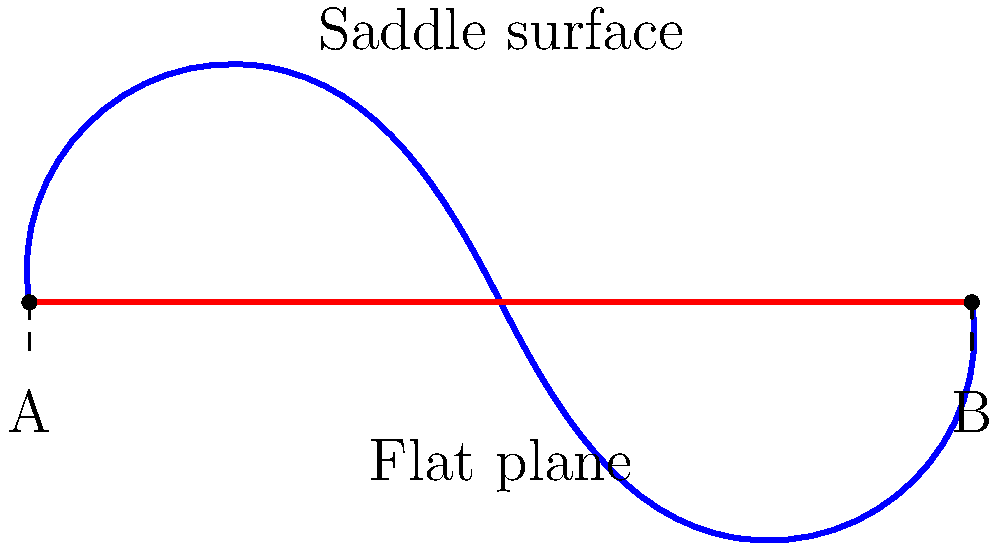As a campus wellness coordinator promoting healthy eating habits, you're designing an interactive display to show how food choices impact overall well-being. You decide to use a non-Euclidean geometry concept to illustrate this. In the diagram, the blue curve represents a saddle-shaped surface, and the red line represents a flat plane. Both connect points A and B. How does the distance between A and B on the saddle surface compare to the distance on the flat plane, and how might this relate to making balanced food choices? To understand this concept and relate it to balanced food choices, let's break it down step-by-step:

1. In Euclidean geometry (flat plane):
   - The shortest distance between two points is a straight line.
   - This is represented by the red line in the diagram.

2. In Non-Euclidean geometry (saddle surface):
   - The shortest path between two points is not necessarily a straight line.
   - The blue curve represents this path on the saddle surface.

3. Comparison of distances:
   - The blue curve (saddle surface path) is longer than the red line (flat plane path).
   - This is because the saddle surface has curvature, causing the path to deviate from a straight line.

4. Relating to balanced food choices:
   - The flat plane (red line) could represent a simplistic view of nutrition, focusing on just one aspect (e.g., calorie counting).
   - The saddle surface (blue curve) could represent a more holistic approach to nutrition, considering multiple factors (e.g., macronutrients, micronutrients, portion sizes, timing of meals).

5. Implications for wellness:
   - Just as the shortest path in non-Euclidean geometry isn't always a straight line, the best approach to nutrition isn't always the most straightforward.
   - A balanced diet may require more "distance" or effort but leads to better overall health outcomes.

6. Educational message:
   - This illustration can help students understand that making healthy food choices involves considering multiple factors, not just following a single, simple rule.
Answer: The distance on the saddle surface is longer, illustrating that a balanced approach to nutrition considers multiple factors and may require more effort but leads to better overall health outcomes. 